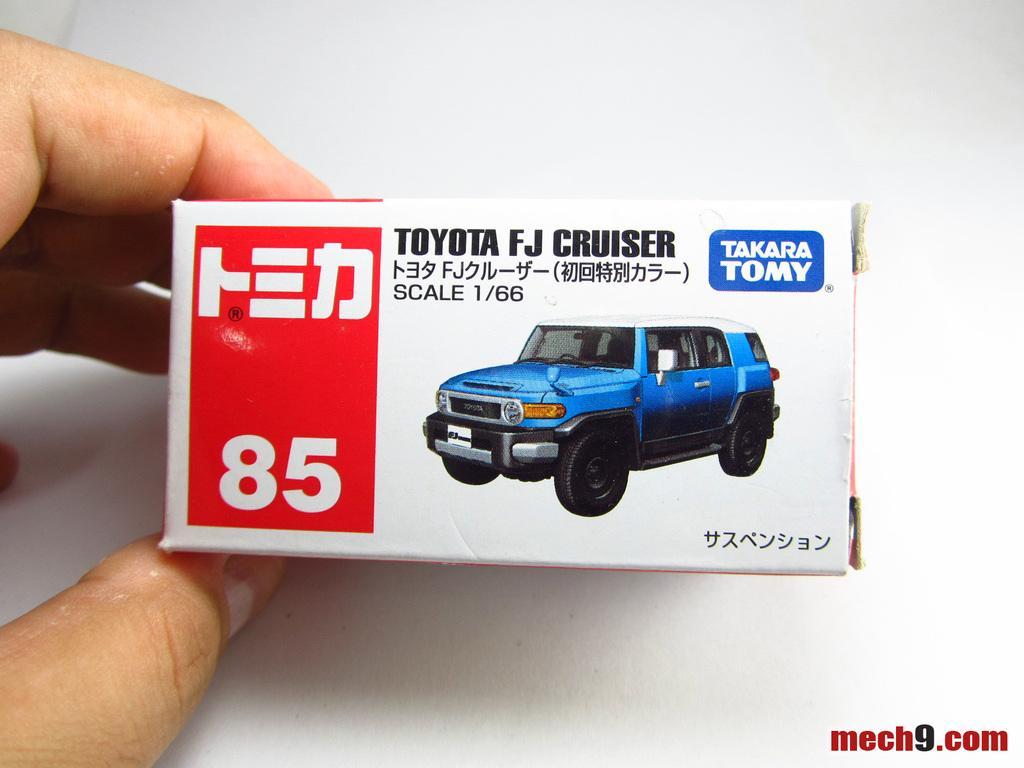In one or two sentences, can you explain what this image depicts? In this image, on the left side, we can see fingers of a person holding a box. In that box, we can see a vehicle. In the background, we can see white color. 